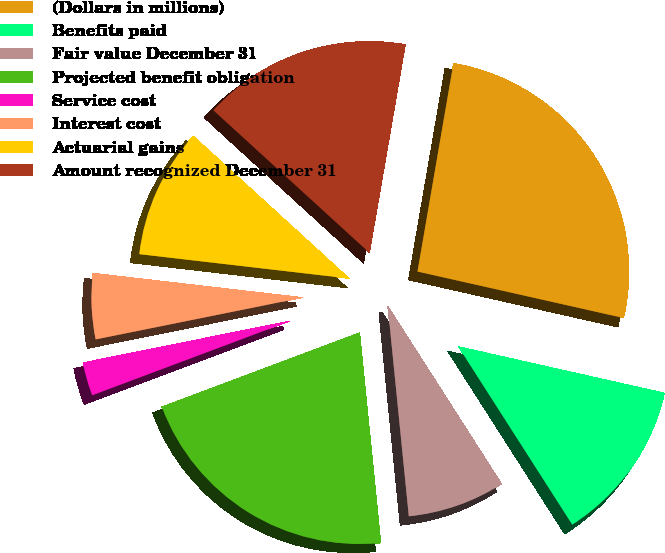Convert chart. <chart><loc_0><loc_0><loc_500><loc_500><pie_chart><fcel>(Dollars in millions)<fcel>Benefits paid<fcel>Fair value December 31<fcel>Projected benefit obligation<fcel>Service cost<fcel>Interest cost<fcel>Actuarial gains<fcel>Amount recognized December 31<nl><fcel>25.81%<fcel>12.41%<fcel>7.47%<fcel>20.88%<fcel>2.54%<fcel>5.01%<fcel>9.94%<fcel>15.94%<nl></chart> 